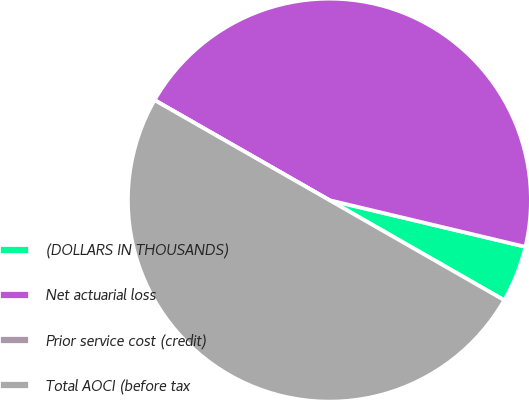Convert chart to OTSL. <chart><loc_0><loc_0><loc_500><loc_500><pie_chart><fcel>(DOLLARS IN THOUSANDS)<fcel>Net actuarial loss<fcel>Prior service cost (credit)<fcel>Total AOCI (before tax<nl><fcel>4.55%<fcel>45.45%<fcel>0.0%<fcel>50.0%<nl></chart> 